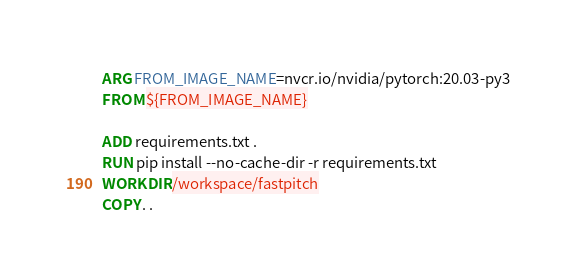<code> <loc_0><loc_0><loc_500><loc_500><_Dockerfile_>ARG FROM_IMAGE_NAME=nvcr.io/nvidia/pytorch:20.03-py3
FROM ${FROM_IMAGE_NAME}

ADD requirements.txt .
RUN pip install --no-cache-dir -r requirements.txt
WORKDIR /workspace/fastpitch
COPY . .
</code> 